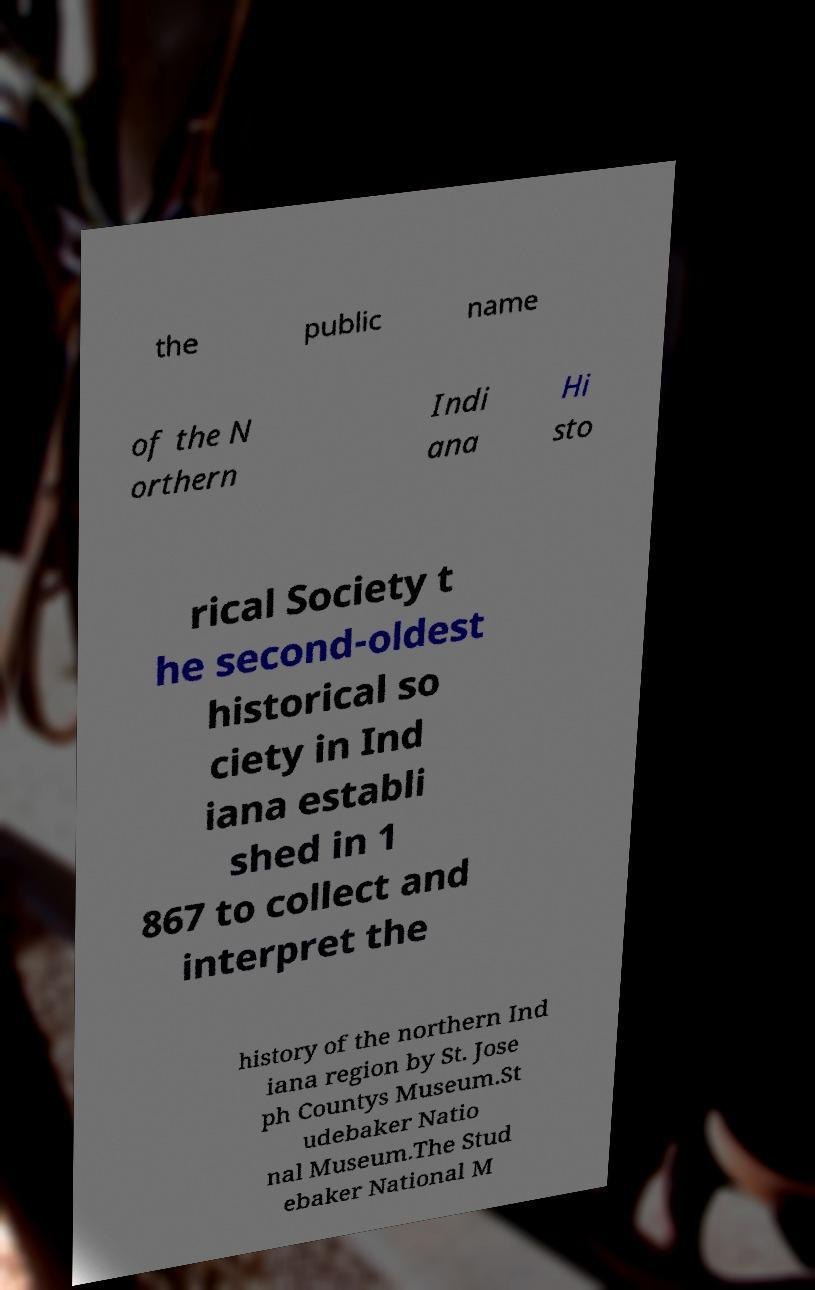Please identify and transcribe the text found in this image. the public name of the N orthern Indi ana Hi sto rical Society t he second-oldest historical so ciety in Ind iana establi shed in 1 867 to collect and interpret the history of the northern Ind iana region by St. Jose ph Countys Museum.St udebaker Natio nal Museum.The Stud ebaker National M 